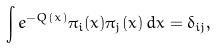<formula> <loc_0><loc_0><loc_500><loc_500>\int e ^ { - Q ( x ) } \pi _ { i } ( x ) \pi _ { j } ( x ) \, d x = \delta _ { i j } ,</formula> 